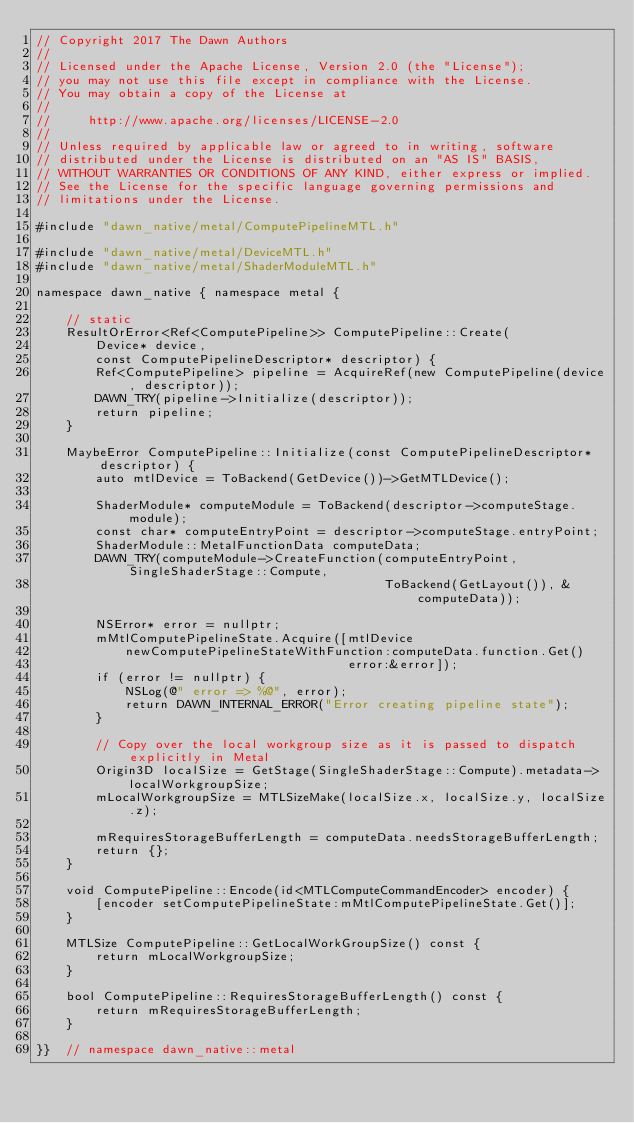<code> <loc_0><loc_0><loc_500><loc_500><_ObjectiveC_>// Copyright 2017 The Dawn Authors
//
// Licensed under the Apache License, Version 2.0 (the "License");
// you may not use this file except in compliance with the License.
// You may obtain a copy of the License at
//
//     http://www.apache.org/licenses/LICENSE-2.0
//
// Unless required by applicable law or agreed to in writing, software
// distributed under the License is distributed on an "AS IS" BASIS,
// WITHOUT WARRANTIES OR CONDITIONS OF ANY KIND, either express or implied.
// See the License for the specific language governing permissions and
// limitations under the License.

#include "dawn_native/metal/ComputePipelineMTL.h"

#include "dawn_native/metal/DeviceMTL.h"
#include "dawn_native/metal/ShaderModuleMTL.h"

namespace dawn_native { namespace metal {

    // static
    ResultOrError<Ref<ComputePipeline>> ComputePipeline::Create(
        Device* device,
        const ComputePipelineDescriptor* descriptor) {
        Ref<ComputePipeline> pipeline = AcquireRef(new ComputePipeline(device, descriptor));
        DAWN_TRY(pipeline->Initialize(descriptor));
        return pipeline;
    }

    MaybeError ComputePipeline::Initialize(const ComputePipelineDescriptor* descriptor) {
        auto mtlDevice = ToBackend(GetDevice())->GetMTLDevice();

        ShaderModule* computeModule = ToBackend(descriptor->computeStage.module);
        const char* computeEntryPoint = descriptor->computeStage.entryPoint;
        ShaderModule::MetalFunctionData computeData;
        DAWN_TRY(computeModule->CreateFunction(computeEntryPoint, SingleShaderStage::Compute,
                                               ToBackend(GetLayout()), &computeData));

        NSError* error = nullptr;
        mMtlComputePipelineState.Acquire([mtlDevice
            newComputePipelineStateWithFunction:computeData.function.Get()
                                          error:&error]);
        if (error != nullptr) {
            NSLog(@" error => %@", error);
            return DAWN_INTERNAL_ERROR("Error creating pipeline state");
        }

        // Copy over the local workgroup size as it is passed to dispatch explicitly in Metal
        Origin3D localSize = GetStage(SingleShaderStage::Compute).metadata->localWorkgroupSize;
        mLocalWorkgroupSize = MTLSizeMake(localSize.x, localSize.y, localSize.z);

        mRequiresStorageBufferLength = computeData.needsStorageBufferLength;
        return {};
    }

    void ComputePipeline::Encode(id<MTLComputeCommandEncoder> encoder) {
        [encoder setComputePipelineState:mMtlComputePipelineState.Get()];
    }

    MTLSize ComputePipeline::GetLocalWorkGroupSize() const {
        return mLocalWorkgroupSize;
    }

    bool ComputePipeline::RequiresStorageBufferLength() const {
        return mRequiresStorageBufferLength;
    }

}}  // namespace dawn_native::metal
</code> 